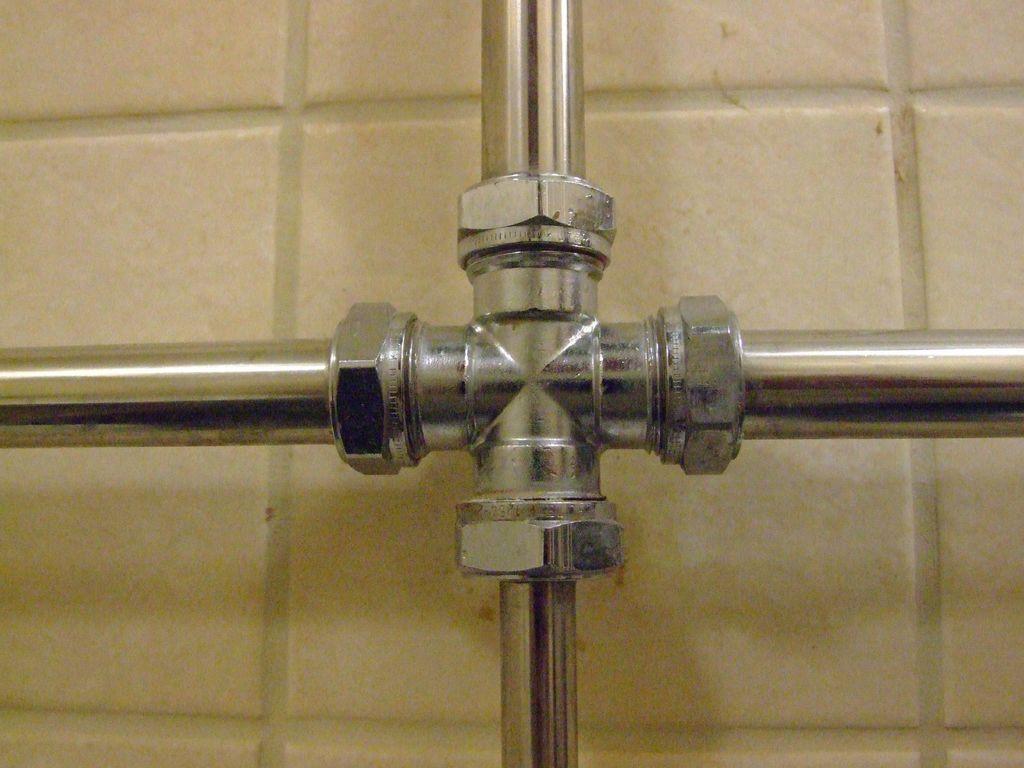In one or two sentences, can you explain what this image depicts? This picture consists of metal object in the center of the image. 